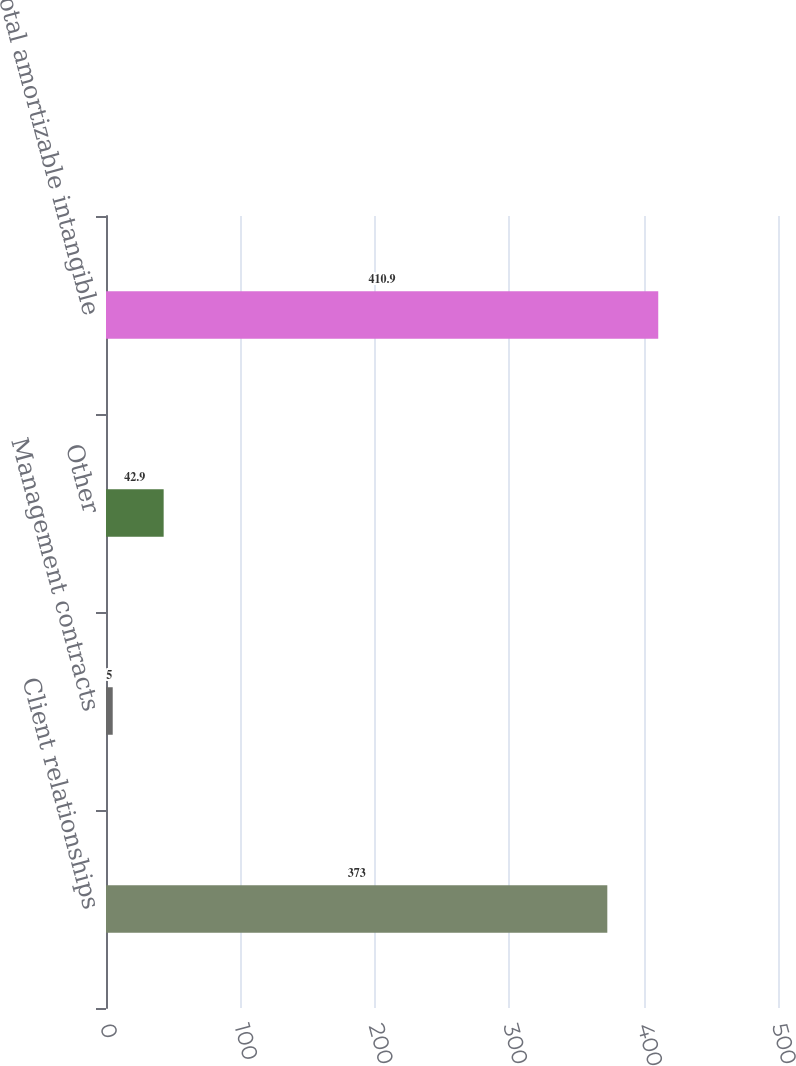<chart> <loc_0><loc_0><loc_500><loc_500><bar_chart><fcel>Client relationships<fcel>Management contracts<fcel>Other<fcel>Total amortizable intangible<nl><fcel>373<fcel>5<fcel>42.9<fcel>410.9<nl></chart> 